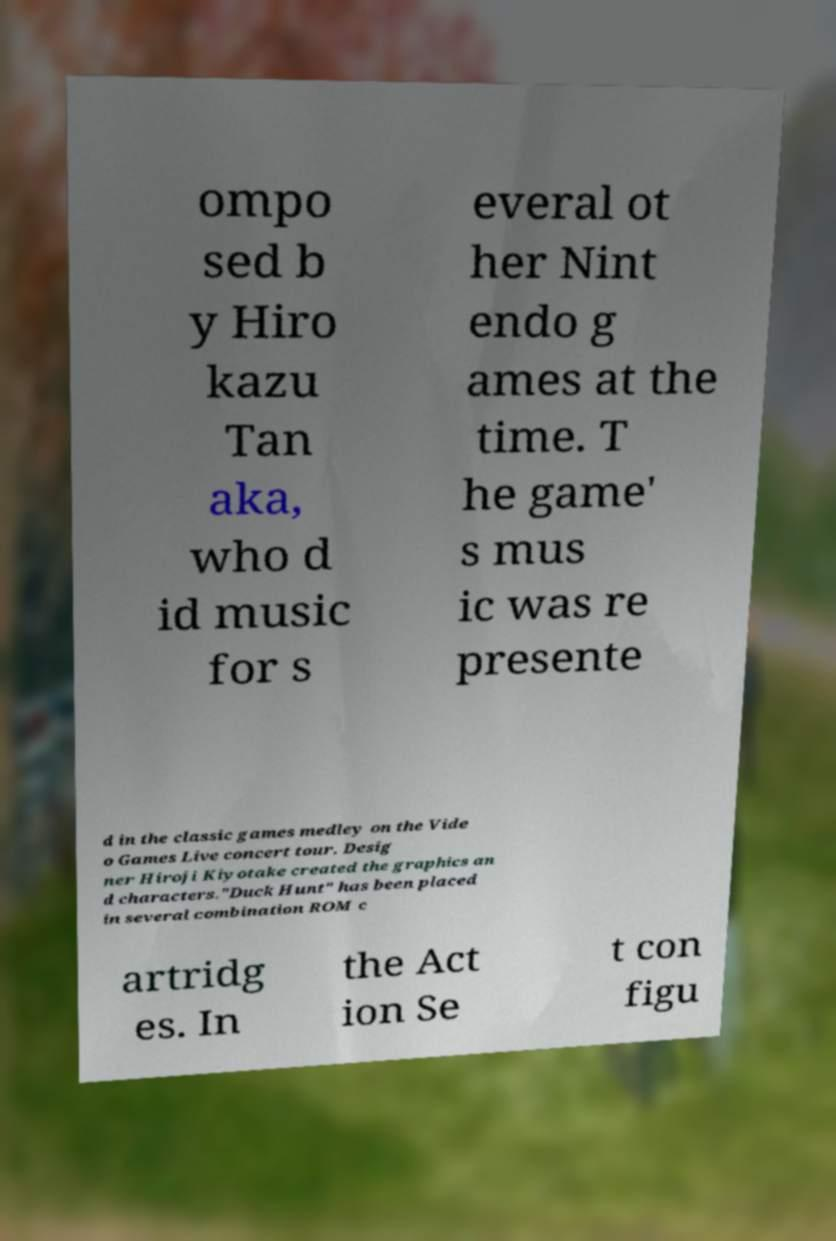There's text embedded in this image that I need extracted. Can you transcribe it verbatim? ompo sed b y Hiro kazu Tan aka, who d id music for s everal ot her Nint endo g ames at the time. T he game' s mus ic was re presente d in the classic games medley on the Vide o Games Live concert tour. Desig ner Hiroji Kiyotake created the graphics an d characters."Duck Hunt" has been placed in several combination ROM c artridg es. In the Act ion Se t con figu 